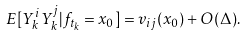Convert formula to latex. <formula><loc_0><loc_0><loc_500><loc_500>E [ Y ^ { i } _ { k } Y ^ { j } _ { k } | f _ { t _ { k } } = x _ { 0 } ] = v _ { i j } ( x _ { 0 } ) + O ( \Delta ) .</formula> 